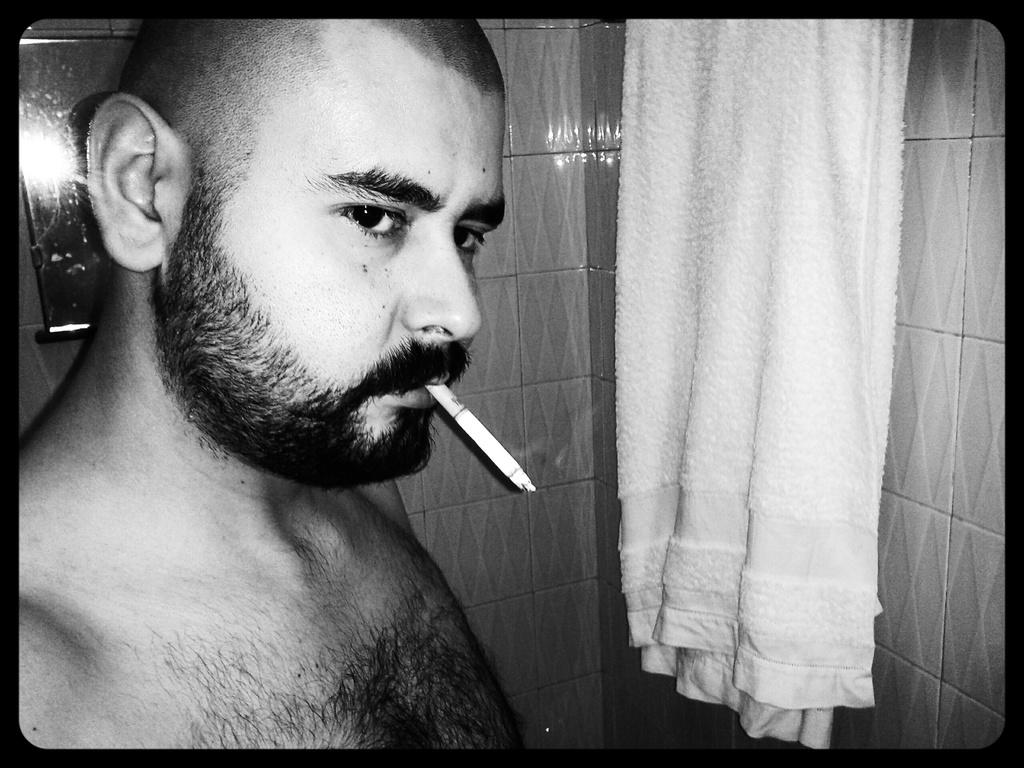Who is present in the image? There is a man in the image. What is the man holding in the image? The man is holding a cigarette. What object is in front of the man? There is a towel in front of the man. What is the color scheme of the image? The image is in black and white. How many eggs are visible in the image? There are no eggs present in the image. What type of cord is being used by the man in the image? There is no cord visible in the image. 